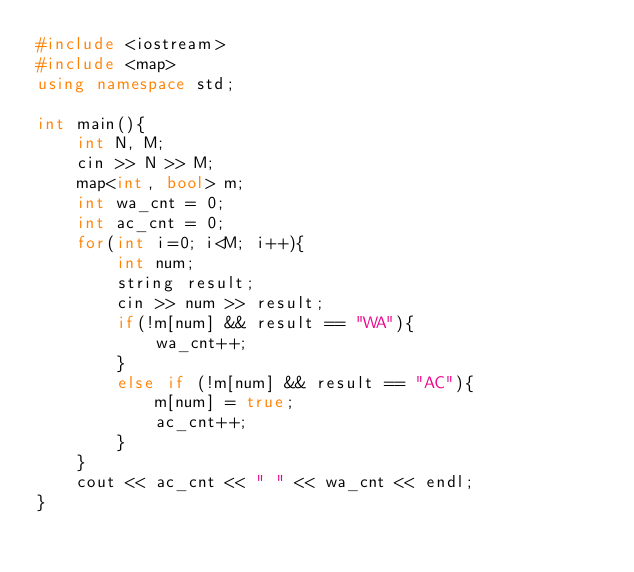<code> <loc_0><loc_0><loc_500><loc_500><_C++_>#include <iostream>
#include <map>
using namespace std;

int main(){
    int N, M;
    cin >> N >> M;
    map<int, bool> m;
    int wa_cnt = 0;
    int ac_cnt = 0;
    for(int i=0; i<M; i++){
        int num;
        string result;
        cin >> num >> result;
        if(!m[num] && result == "WA"){
            wa_cnt++;
        }
        else if (!m[num] && result == "AC"){
            m[num] = true;
            ac_cnt++;
        }
    }
    cout << ac_cnt << " " << wa_cnt << endl;
}
</code> 